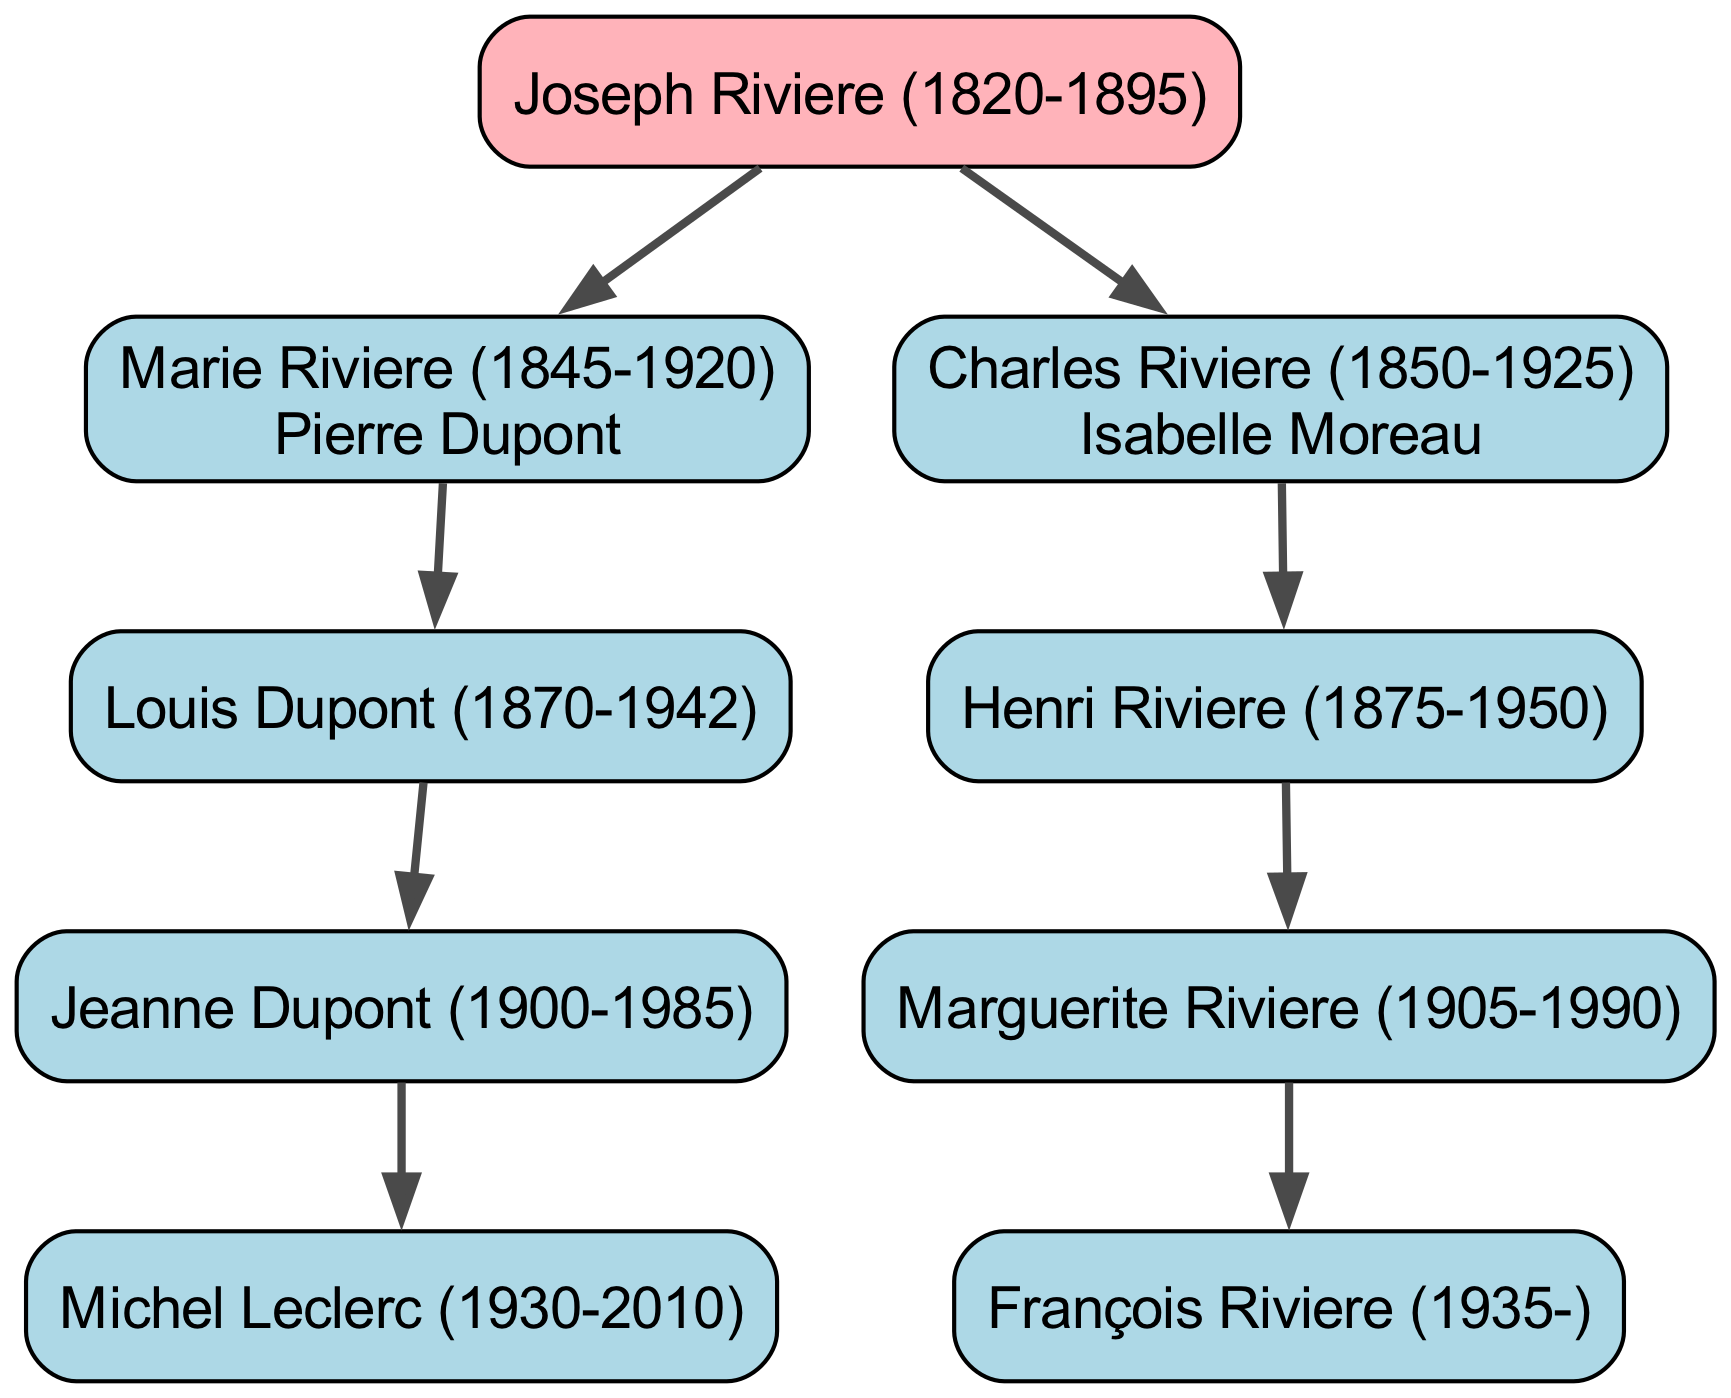What is the full name of the root of the genealogy tree? The root of the genealogy tree is explicitly labeled in the diagram as Joseph Riviere, followed by his birth and death years (1820-1895).
Answer: Joseph Riviere (1820-1895) How many children does Charles Riviere have? By examining the diagram, we see that Charles Riviere has one child, Henri Riviere, indicated by a single branch coming from his node.
Answer: 1 Who is the spouse of Marie Riviere? The diagram indicates Marie Riviere is married to Pierre Dupont, as their names are connected through a line indicating marriage, which is placed next to her name in the diagram.
Answer: Pierre Dupont Which generation does Michel Leclerc belong to? Following the diagram, we trace back from Michel Leclerc who is the child of Jeanne Dupont. Jeanne Dupont is in the third generation, meaning Michel Leclerc is in the fourth generation in the tree.
Answer: Fourth generation What is the relationship between François Riviere and Joseph Riviere? To determine the relationship, we can check the hierarchy in the diagram. François Riviere is the great-grandson of Joseph Riviere, as he descends from his grandchild (Henri Riviere).
Answer: Great-grandson How many grandchildren does Marie Riviere have? In the diagram, Marie Riviere has one child (Louis Dupont) and that child also has one child (Jeanne Dupont). Therefore, Marie Riviere has one grandchild based on the structure shown.
Answer: 1 Who are the direct descendants of Pierre Dupont? According to the diagram, the direct descendants of Pierre Dupont would include his children – in this case, he has one child, Louis Dupont. Therefore, we note the lineage directly attributed to Pierre.
Answer: Louis Dupont What visual structure connects Henri Riviere to Joseph Riviere? The diagram represents the family relationship visually with lines connecting parent to child. Henri Riviere is connected to Joseph Riviere through Charles Riviere, establishing a two-step link.
Answer: Two lines (Charles Riviere and then Henri Riviere) 